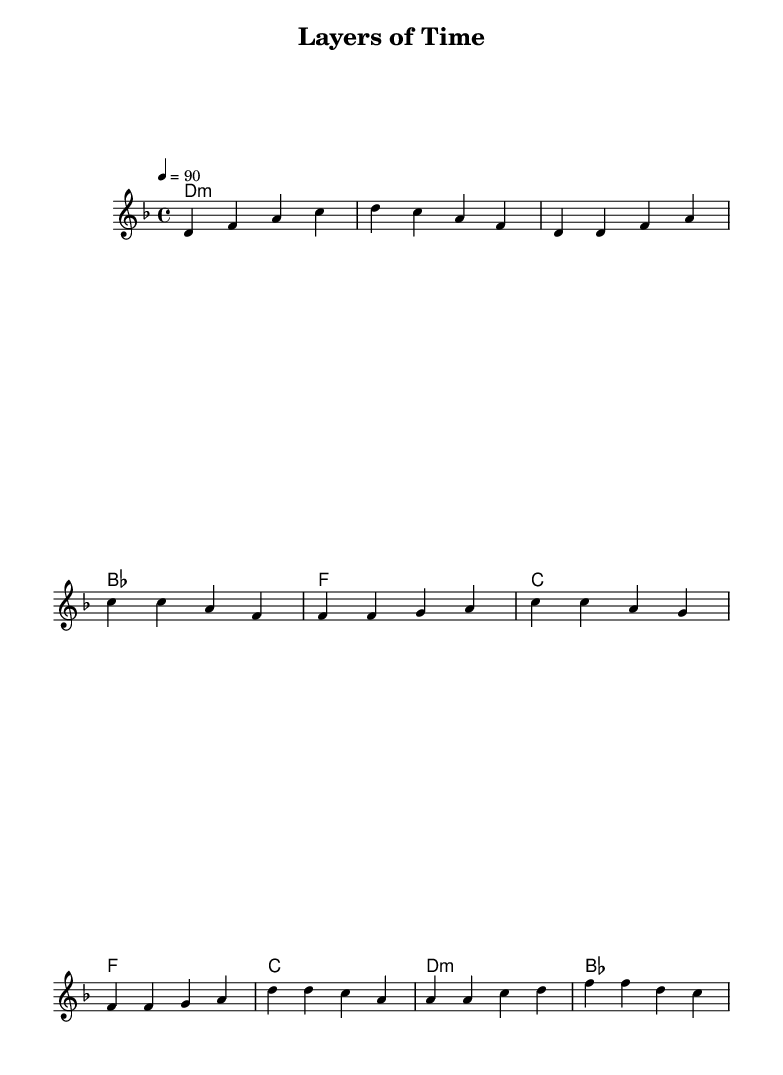What is the key signature of this music? The key signature is indicated by the absence of any sharps or flats placed at the beginning of the staff. The presence of a key signature with no symbols signifies D minor.
Answer: D minor What is the time signature of the piece? The time signature is shown as a fraction, indicating four beats per measure, signified by '4/4' at the beginning of the score. This means there are four quarter note beats in each measure.
Answer: 4/4 What is the tempo marking of this piece? The tempo marking is found at the top of the score, stating '4 = 90'. This indicates that each quarter note is to be played at a speed of 90 beats per minute.
Answer: 90 How many measures are in the chorus section? To determine this, count the number of distinct groups of notes between the bar lines in the chorus section labeled in the score, which breaks down into four measures.
Answer: 4 What is the first note of the melody? The first note is indicated at the start of the melody line in the first measure, represented by the letter 'd' in the second octave.
Answer: D What is the harmonic structure in the first two measures? The harmonic structure is identifiable from the chord names below the staff. In the first two measures, both are labeled as D minor, H representing the minor quality of the chord used.
Answer: D minor What genre of music is this piece considered? The genre is implied through the style, rhythm, and educational content, which aligns with the characteristics commonly found in rap music, especially as it relates to educating on geological concepts.
Answer: Rap 